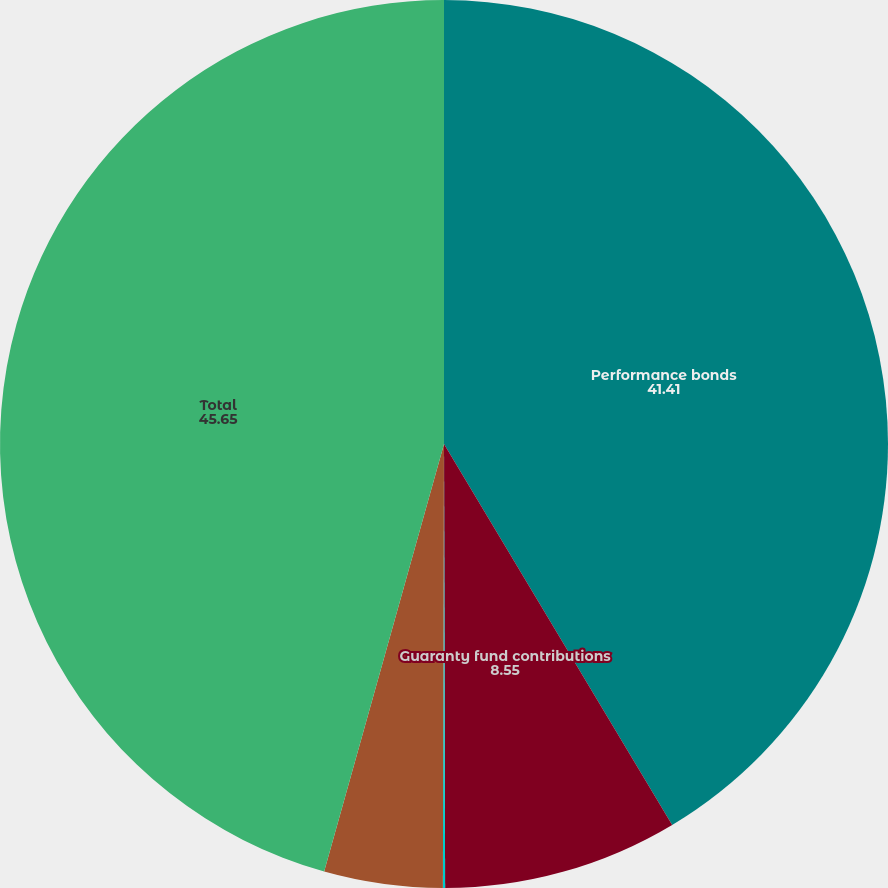<chart> <loc_0><loc_0><loc_500><loc_500><pie_chart><fcel>Performance bonds<fcel>Guaranty fund contributions<fcel>Cross-margin arrangements<fcel>Performance collateral for<fcel>Total<nl><fcel>41.41%<fcel>8.55%<fcel>0.08%<fcel>4.31%<fcel>45.65%<nl></chart> 